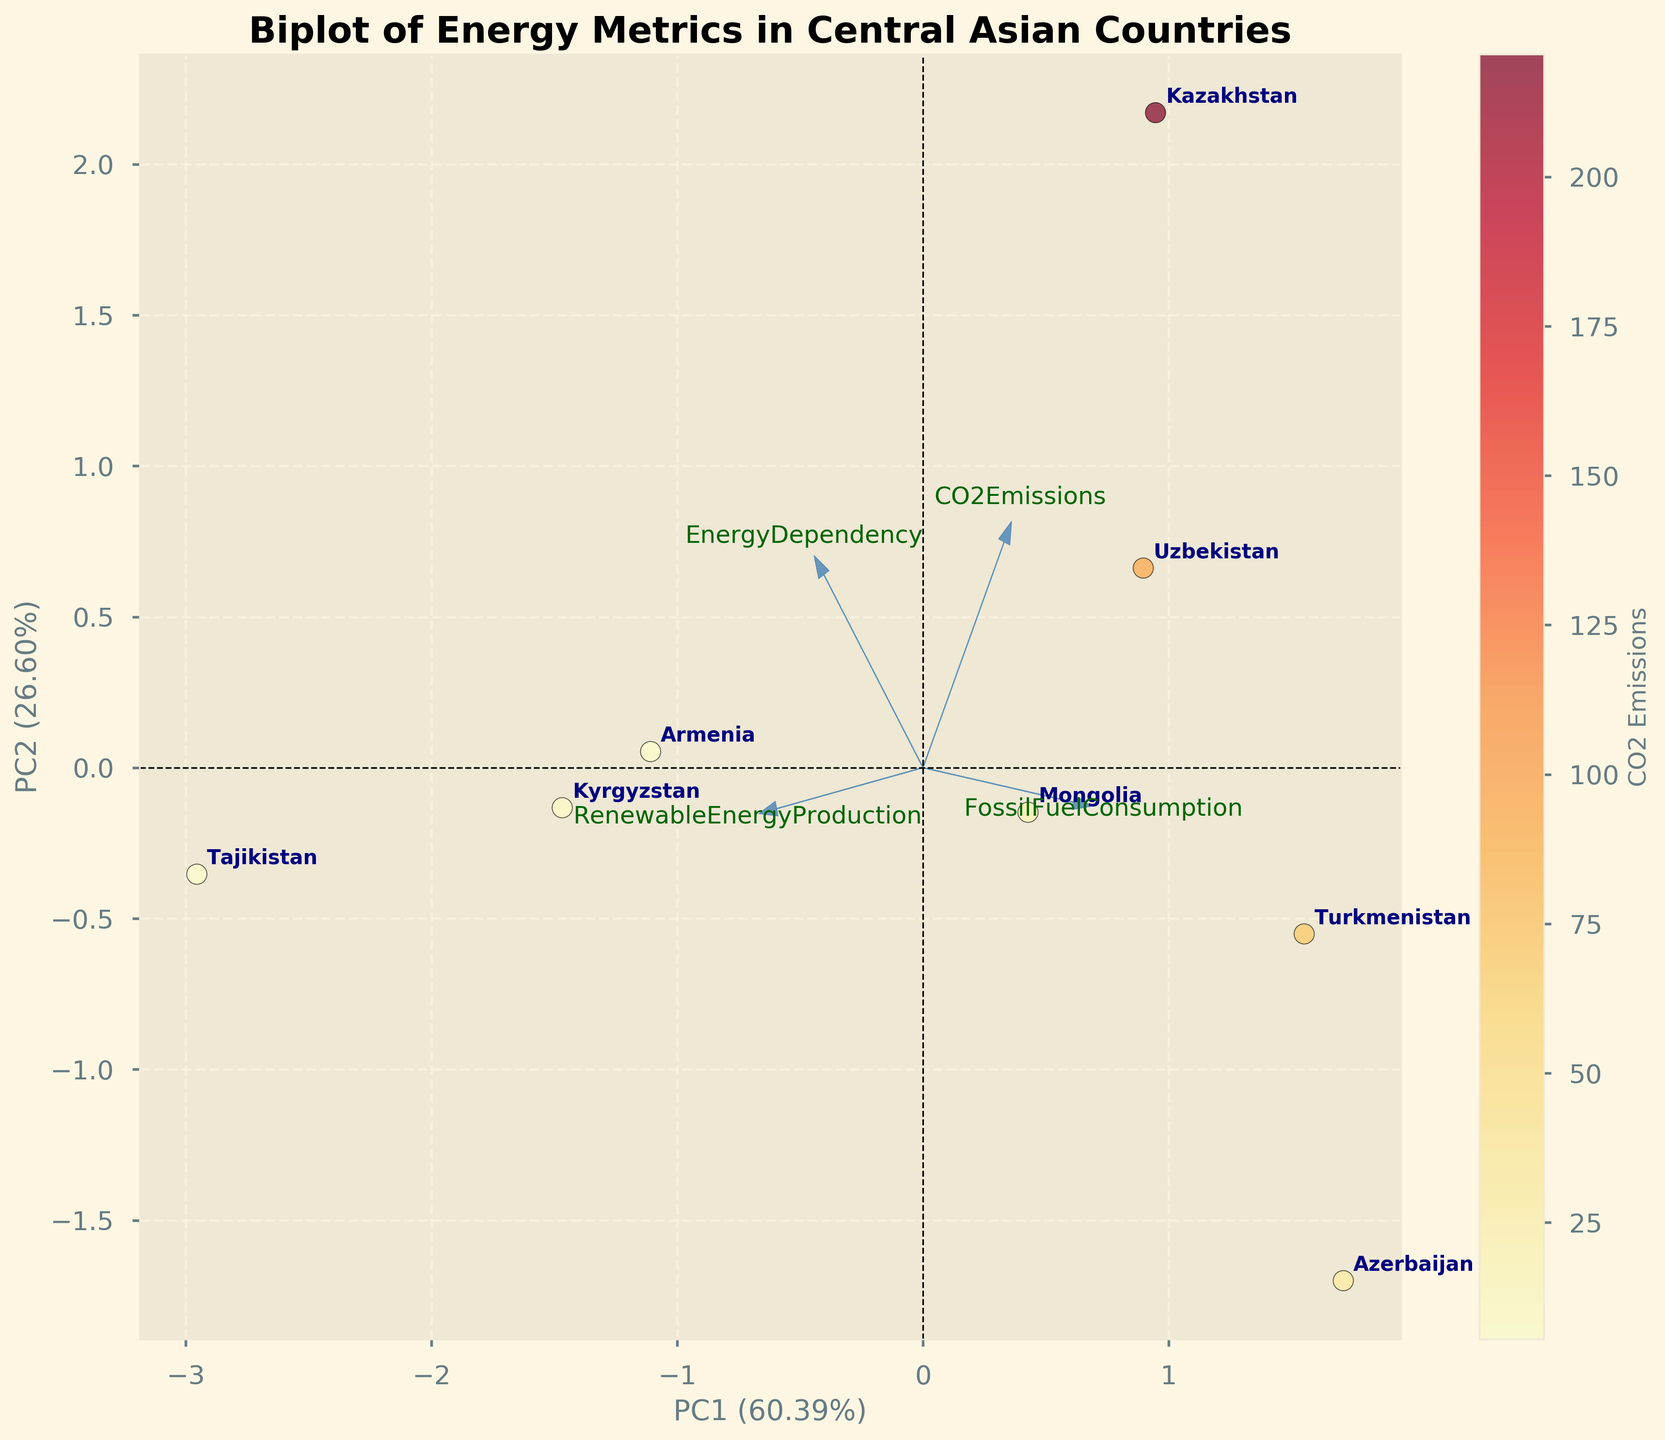What's the title of the plot? The title of the plot is at the top, indicated in bold font. It reads "Biplot of Energy Metrics in Central Asian Countries".
Answer: Biplot of Energy Metrics in Central Asian Countries How many countries are depicted in the plot? The number of countries can be determined by counting the number of labeled data points in the figure. There are eight labels for the countries within the biplot.
Answer: Eight Which country has the highest renewable energy production? By looking at the country names near the higher values indicated by the "RenewableEnergyProduction" axis in the biplot, we can identify that Tajikistan is positioned near the high end of the "RenewableEnergyProduction" vector.
Answer: Tajikistan What does the color of the data points represent? The color of the data points is described in the legend associated with the colorbar, which indicates the color gradient applied is for CO2 emissions.
Answer: CO2 emissions Which country is the most dependent on energy imports? In the plot, the "EnergyDependency" vector indicates this metric, and Armenia is closest to the highest point on this axis.
Answer: Armenia Which two countries have a similar level of CO2 emissions but different levels of renewable energy production? By observing the color gradient (representing CO2 emissions) and the placement near the "RenewableEnergyProduction" vector, we see that Kazakhstan and Armenia have similar CO2 emission colors but significantly different positions along the renewable energy production vector.
Answer: Kazakhstan and Armenia Compare Fossil Fuel Consumption and Renewable Energy Production between Kazakhstan and Kyrgyzstan. In the plot, Kazakhstan is closer to the "FossilFuelConsumption" vector while Kyrgyzstan is closer to the "RenewableEnergyProduction" vector, indicating Kazakhstan has a higher fossil fuel consumption, and Kyrgyzstan has higher renewable energy production.
Answer: Kazakhstan has higher fossil fuel consumption, and Kyrgyzstan has higher renewable energy production What proportion of the variance is explained by the first Principal Component (PC1)? The x-axis label includes the explained variance ratio, showing 50.76%. Therefore, around 50.76% of the variance in the data is explained by PC1.
Answer: 50.76% Which feature is most closely associated with PC2? The feature most closely associated with PC2 can be seen from the loadings plot. The axis corresponding to "RenewableEnergyProduction" has the highest loading on PC2, looking at the vectors' lengths and directions.
Answer: RenewableEnergyProduction Which country has the lowest energy dependency and how does it compare to its CO2 emissions? By observing the "EnergyDependency" vector, Azerbaijan is the country indicated at a much lower value. Referring to the color bar for CO2 emissions, Azerbaijan has a moderate CO2 emission level.
Answer: Azerbaijan, moderate CO2 emissions 